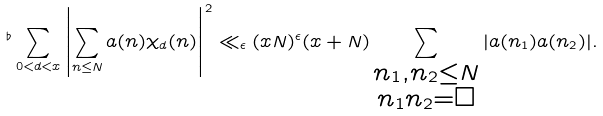Convert formula to latex. <formula><loc_0><loc_0><loc_500><loc_500>{ ^ { \flat } } \sum _ { 0 < d < x } \left | \sum _ { n \leq N } a ( n ) \chi _ { d } ( n ) \right | ^ { 2 } \ll _ { \epsilon } ( x N ) ^ { \epsilon } ( x + N ) \sum _ { \substack { n _ { 1 } , n _ { 2 } \leq N \\ n _ { 1 } n _ { 2 } = \square } } | a ( n _ { 1 } ) a ( n _ { 2 } ) | .</formula> 